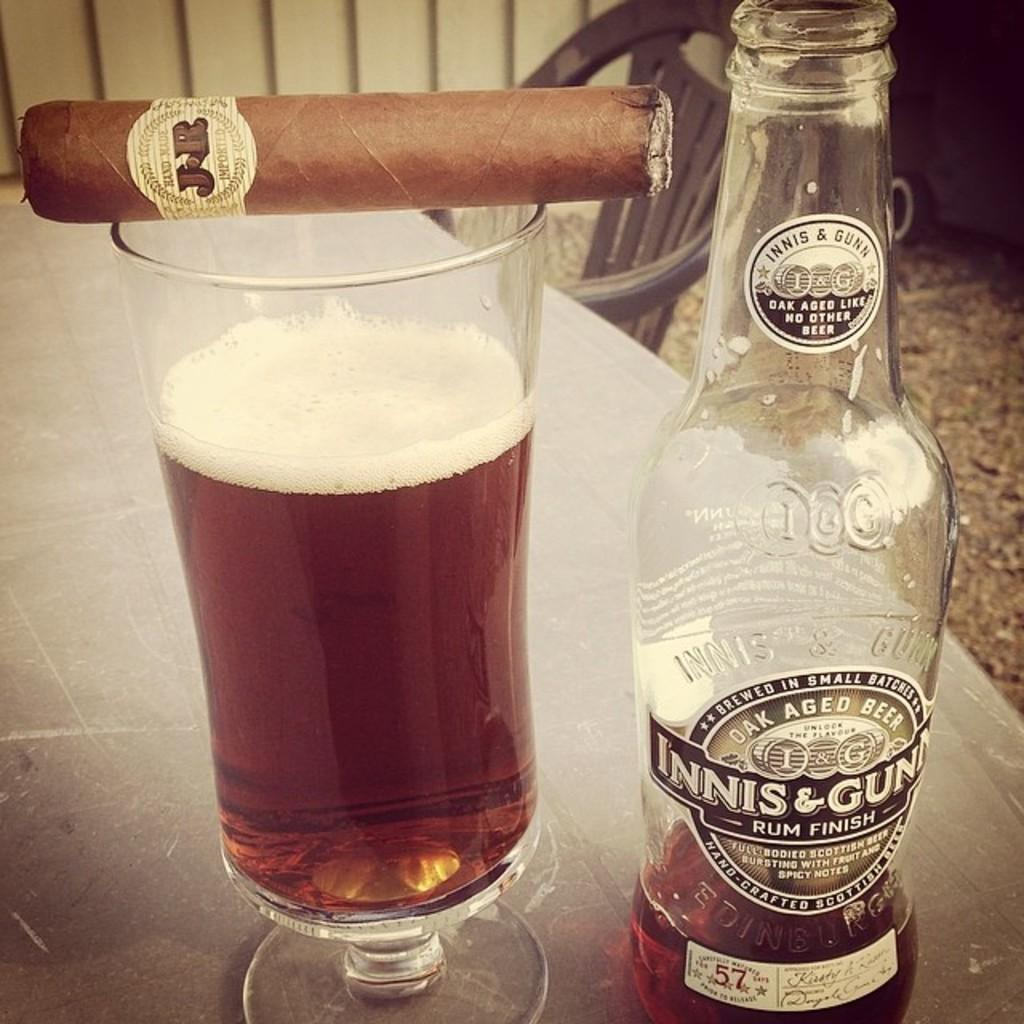<image>
Present a compact description of the photo's key features. A bottle of liquor contains rum by Innis & Gunn. 